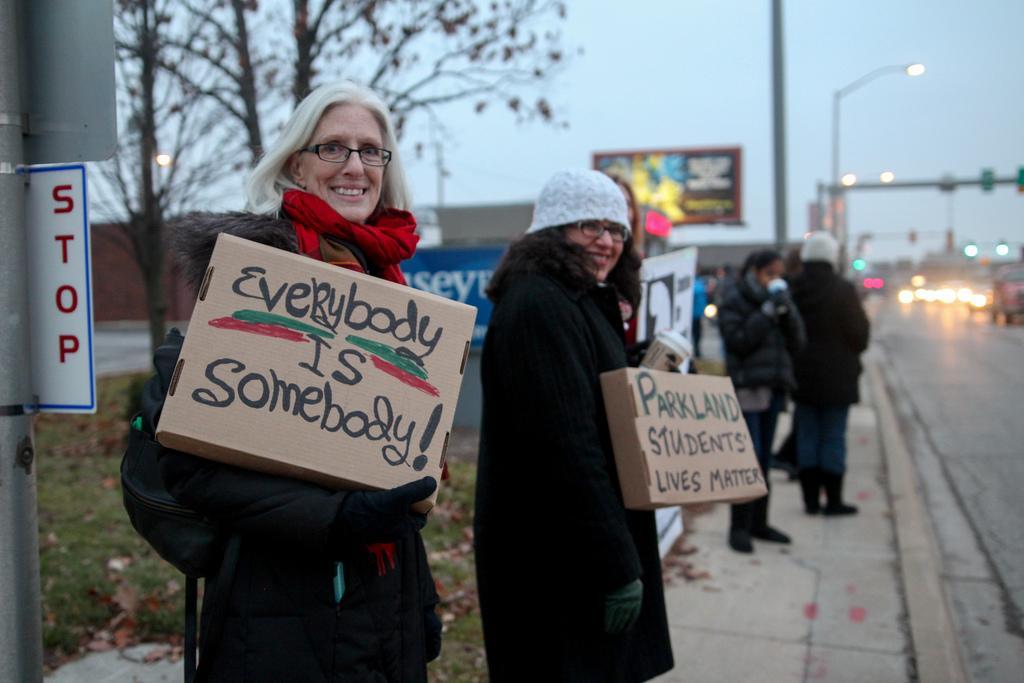How would you summarize this image in a sentence or two? On the left side there is a pole with a sign board. Lady near to that is wearing gloves and scarf is holding a box with something written on that. Another lady wearing a cap and specs is holding a box with something written. There are many people standing on the sidewalk. On the right side there is a road. In the background there are trees, boards, poles and sky. Also there are lights. 